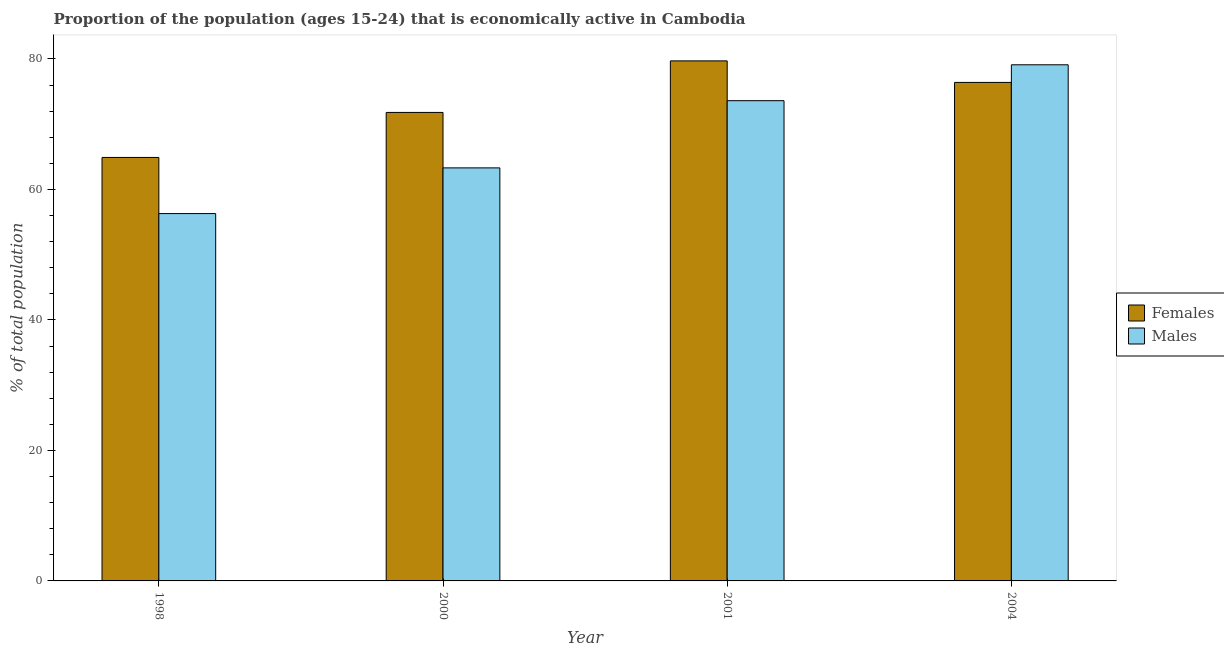Are the number of bars per tick equal to the number of legend labels?
Keep it short and to the point. Yes. Are the number of bars on each tick of the X-axis equal?
Offer a very short reply. Yes. How many bars are there on the 4th tick from the right?
Offer a very short reply. 2. What is the label of the 3rd group of bars from the left?
Keep it short and to the point. 2001. What is the percentage of economically active female population in 2000?
Provide a succinct answer. 71.8. Across all years, what is the maximum percentage of economically active male population?
Keep it short and to the point. 79.1. Across all years, what is the minimum percentage of economically active male population?
Your response must be concise. 56.3. In which year was the percentage of economically active female population maximum?
Keep it short and to the point. 2001. In which year was the percentage of economically active male population minimum?
Ensure brevity in your answer.  1998. What is the total percentage of economically active female population in the graph?
Your answer should be compact. 292.8. What is the difference between the percentage of economically active female population in 1998 and that in 2000?
Provide a short and direct response. -6.9. What is the difference between the percentage of economically active female population in 1998 and the percentage of economically active male population in 2000?
Provide a short and direct response. -6.9. What is the average percentage of economically active male population per year?
Offer a very short reply. 68.07. In the year 2001, what is the difference between the percentage of economically active male population and percentage of economically active female population?
Your answer should be very brief. 0. What is the ratio of the percentage of economically active male population in 2001 to that in 2004?
Your response must be concise. 0.93. Is the percentage of economically active male population in 2001 less than that in 2004?
Give a very brief answer. Yes. What is the difference between the highest and the lowest percentage of economically active male population?
Make the answer very short. 22.8. Is the sum of the percentage of economically active male population in 1998 and 2001 greater than the maximum percentage of economically active female population across all years?
Keep it short and to the point. Yes. What does the 2nd bar from the left in 1998 represents?
Ensure brevity in your answer.  Males. What does the 2nd bar from the right in 2004 represents?
Make the answer very short. Females. Are the values on the major ticks of Y-axis written in scientific E-notation?
Your answer should be compact. No. Does the graph contain any zero values?
Give a very brief answer. No. How are the legend labels stacked?
Offer a very short reply. Vertical. What is the title of the graph?
Offer a very short reply. Proportion of the population (ages 15-24) that is economically active in Cambodia. Does "Canada" appear as one of the legend labels in the graph?
Offer a very short reply. No. What is the label or title of the X-axis?
Ensure brevity in your answer.  Year. What is the label or title of the Y-axis?
Make the answer very short. % of total population. What is the % of total population in Females in 1998?
Offer a terse response. 64.9. What is the % of total population of Males in 1998?
Give a very brief answer. 56.3. What is the % of total population of Females in 2000?
Make the answer very short. 71.8. What is the % of total population of Males in 2000?
Offer a very short reply. 63.3. What is the % of total population of Females in 2001?
Your answer should be compact. 79.7. What is the % of total population of Males in 2001?
Your answer should be compact. 73.6. What is the % of total population in Females in 2004?
Offer a terse response. 76.4. What is the % of total population in Males in 2004?
Offer a terse response. 79.1. Across all years, what is the maximum % of total population in Females?
Offer a terse response. 79.7. Across all years, what is the maximum % of total population in Males?
Provide a short and direct response. 79.1. Across all years, what is the minimum % of total population in Females?
Give a very brief answer. 64.9. Across all years, what is the minimum % of total population in Males?
Your answer should be compact. 56.3. What is the total % of total population of Females in the graph?
Your answer should be very brief. 292.8. What is the total % of total population in Males in the graph?
Your response must be concise. 272.3. What is the difference between the % of total population of Females in 1998 and that in 2001?
Provide a succinct answer. -14.8. What is the difference between the % of total population of Males in 1998 and that in 2001?
Ensure brevity in your answer.  -17.3. What is the difference between the % of total population in Females in 1998 and that in 2004?
Your answer should be compact. -11.5. What is the difference between the % of total population of Males in 1998 and that in 2004?
Make the answer very short. -22.8. What is the difference between the % of total population in Females in 2000 and that in 2001?
Provide a short and direct response. -7.9. What is the difference between the % of total population of Males in 2000 and that in 2001?
Provide a succinct answer. -10.3. What is the difference between the % of total population in Females in 2000 and that in 2004?
Give a very brief answer. -4.6. What is the difference between the % of total population in Males in 2000 and that in 2004?
Give a very brief answer. -15.8. What is the difference between the % of total population in Females in 2001 and that in 2004?
Provide a succinct answer. 3.3. What is the difference between the % of total population of Females in 2001 and the % of total population of Males in 2004?
Give a very brief answer. 0.6. What is the average % of total population of Females per year?
Provide a succinct answer. 73.2. What is the average % of total population of Males per year?
Offer a very short reply. 68.08. In the year 2001, what is the difference between the % of total population in Females and % of total population in Males?
Your answer should be very brief. 6.1. In the year 2004, what is the difference between the % of total population of Females and % of total population of Males?
Keep it short and to the point. -2.7. What is the ratio of the % of total population of Females in 1998 to that in 2000?
Your answer should be very brief. 0.9. What is the ratio of the % of total population in Males in 1998 to that in 2000?
Keep it short and to the point. 0.89. What is the ratio of the % of total population of Females in 1998 to that in 2001?
Provide a succinct answer. 0.81. What is the ratio of the % of total population of Males in 1998 to that in 2001?
Your answer should be very brief. 0.76. What is the ratio of the % of total population of Females in 1998 to that in 2004?
Provide a short and direct response. 0.85. What is the ratio of the % of total population in Males in 1998 to that in 2004?
Ensure brevity in your answer.  0.71. What is the ratio of the % of total population in Females in 2000 to that in 2001?
Your response must be concise. 0.9. What is the ratio of the % of total population of Males in 2000 to that in 2001?
Provide a short and direct response. 0.86. What is the ratio of the % of total population of Females in 2000 to that in 2004?
Your response must be concise. 0.94. What is the ratio of the % of total population in Males in 2000 to that in 2004?
Offer a very short reply. 0.8. What is the ratio of the % of total population in Females in 2001 to that in 2004?
Your response must be concise. 1.04. What is the ratio of the % of total population in Males in 2001 to that in 2004?
Ensure brevity in your answer.  0.93. What is the difference between the highest and the lowest % of total population of Males?
Keep it short and to the point. 22.8. 